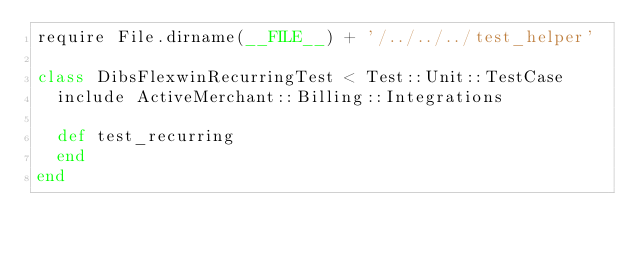<code> <loc_0><loc_0><loc_500><loc_500><_Ruby_>require File.dirname(__FILE__) + '/../../../test_helper'

class DibsFlexwinRecurringTest < Test::Unit::TestCase
  include ActiveMerchant::Billing::Integrations
  
  def test_recurring    
  end
end
</code> 